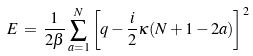Convert formula to latex. <formula><loc_0><loc_0><loc_500><loc_500>E \, = \, \frac { 1 } { 2 \beta } \sum _ { a = 1 } ^ { N } \left [ q - \frac { i } { 2 } \kappa ( N + 1 - 2 a ) \right ] ^ { 2 }</formula> 